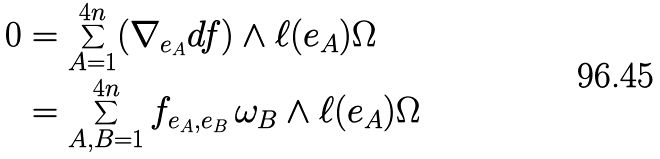<formula> <loc_0><loc_0><loc_500><loc_500>0 & = \sum _ { A = 1 } ^ { 4 n } ( \nabla _ { e _ { A } } d f ) \wedge \ell ( e _ { A } ) \Omega \\ & = \sum _ { A , B = 1 } ^ { 4 n } f _ { e _ { A } , e _ { B } } \, \omega _ { B } \wedge \ell ( e _ { A } ) \Omega</formula> 